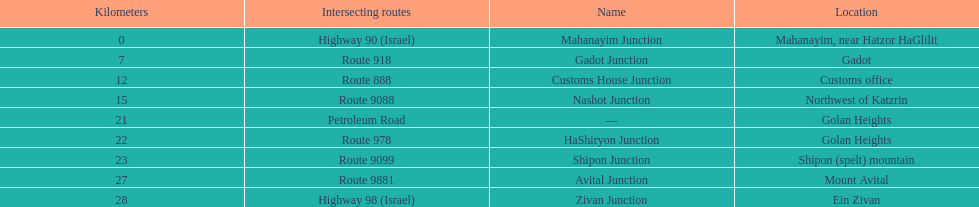What is the last junction on highway 91? Zivan Junction. 